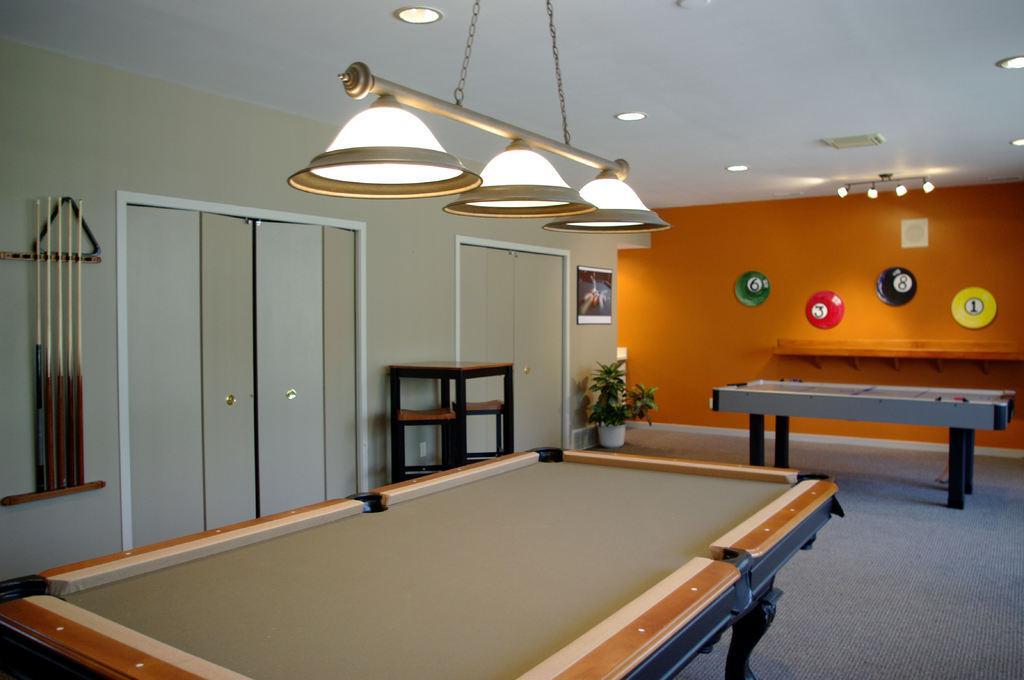How would you summarize this image in a sentence or two? In this picture that is a snooker table and in the backdrop there is a Orange wall and as lights attached to the ceiling 